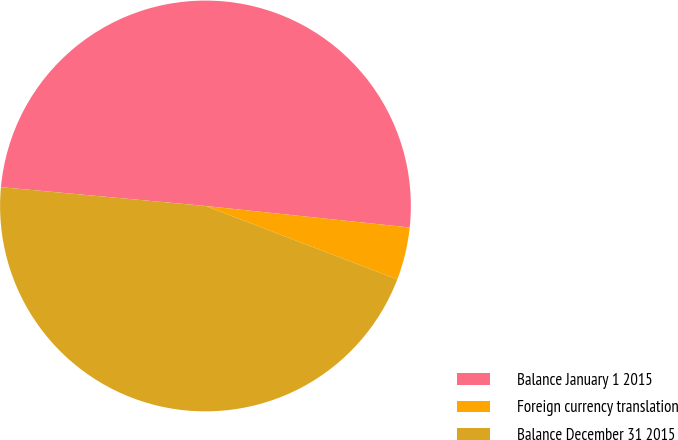Convert chart. <chart><loc_0><loc_0><loc_500><loc_500><pie_chart><fcel>Balance January 1 2015<fcel>Foreign currency translation<fcel>Balance December 31 2015<nl><fcel>50.21%<fcel>4.15%<fcel>45.64%<nl></chart> 